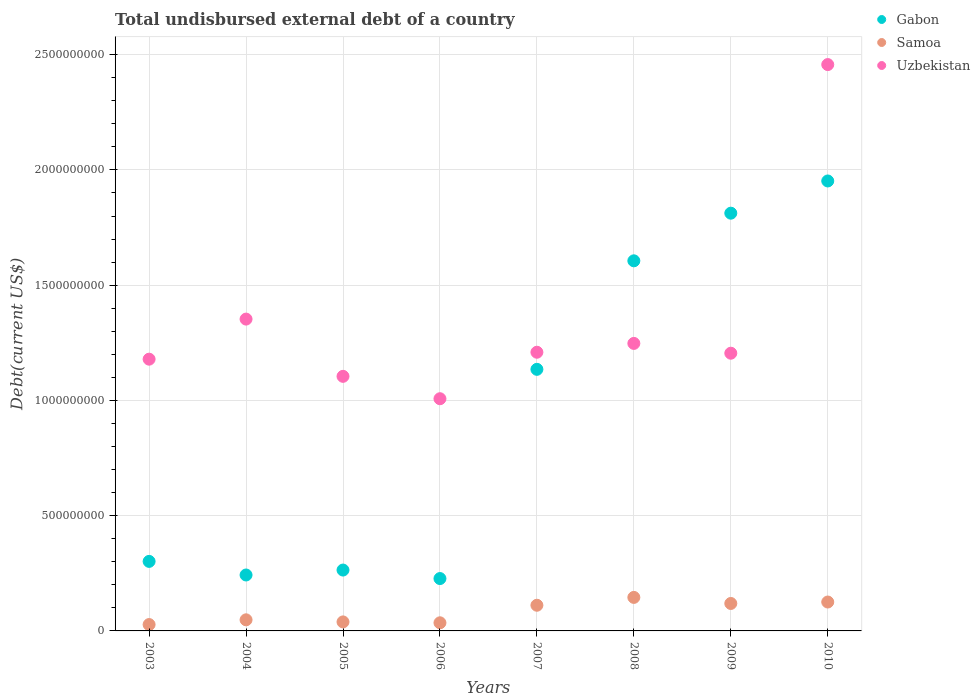Is the number of dotlines equal to the number of legend labels?
Your response must be concise. Yes. What is the total undisbursed external debt in Samoa in 2004?
Offer a terse response. 4.82e+07. Across all years, what is the maximum total undisbursed external debt in Uzbekistan?
Provide a short and direct response. 2.46e+09. Across all years, what is the minimum total undisbursed external debt in Samoa?
Ensure brevity in your answer.  2.76e+07. In which year was the total undisbursed external debt in Gabon minimum?
Keep it short and to the point. 2006. What is the total total undisbursed external debt in Samoa in the graph?
Give a very brief answer. 6.51e+08. What is the difference between the total undisbursed external debt in Gabon in 2004 and that in 2005?
Keep it short and to the point. -2.14e+07. What is the difference between the total undisbursed external debt in Gabon in 2007 and the total undisbursed external debt in Samoa in 2009?
Your response must be concise. 1.02e+09. What is the average total undisbursed external debt in Gabon per year?
Your answer should be very brief. 9.43e+08. In the year 2007, what is the difference between the total undisbursed external debt in Samoa and total undisbursed external debt in Uzbekistan?
Offer a very short reply. -1.10e+09. In how many years, is the total undisbursed external debt in Gabon greater than 2000000000 US$?
Make the answer very short. 0. What is the ratio of the total undisbursed external debt in Gabon in 2004 to that in 2008?
Make the answer very short. 0.15. Is the difference between the total undisbursed external debt in Samoa in 2006 and 2008 greater than the difference between the total undisbursed external debt in Uzbekistan in 2006 and 2008?
Your response must be concise. Yes. What is the difference between the highest and the second highest total undisbursed external debt in Samoa?
Provide a short and direct response. 2.00e+07. What is the difference between the highest and the lowest total undisbursed external debt in Samoa?
Your answer should be very brief. 1.18e+08. Is it the case that in every year, the sum of the total undisbursed external debt in Gabon and total undisbursed external debt in Samoa  is greater than the total undisbursed external debt in Uzbekistan?
Make the answer very short. No. Does the total undisbursed external debt in Gabon monotonically increase over the years?
Give a very brief answer. No. Is the total undisbursed external debt in Samoa strictly less than the total undisbursed external debt in Gabon over the years?
Make the answer very short. Yes. How many years are there in the graph?
Keep it short and to the point. 8. What is the difference between two consecutive major ticks on the Y-axis?
Ensure brevity in your answer.  5.00e+08. Are the values on the major ticks of Y-axis written in scientific E-notation?
Provide a short and direct response. No. Does the graph contain any zero values?
Keep it short and to the point. No. Where does the legend appear in the graph?
Offer a very short reply. Top right. How many legend labels are there?
Make the answer very short. 3. What is the title of the graph?
Keep it short and to the point. Total undisbursed external debt of a country. What is the label or title of the Y-axis?
Offer a very short reply. Debt(current US$). What is the Debt(current US$) in Gabon in 2003?
Provide a short and direct response. 3.02e+08. What is the Debt(current US$) of Samoa in 2003?
Ensure brevity in your answer.  2.76e+07. What is the Debt(current US$) of Uzbekistan in 2003?
Your response must be concise. 1.18e+09. What is the Debt(current US$) of Gabon in 2004?
Provide a succinct answer. 2.43e+08. What is the Debt(current US$) in Samoa in 2004?
Ensure brevity in your answer.  4.82e+07. What is the Debt(current US$) of Uzbekistan in 2004?
Ensure brevity in your answer.  1.35e+09. What is the Debt(current US$) of Gabon in 2005?
Your response must be concise. 2.64e+08. What is the Debt(current US$) in Samoa in 2005?
Provide a short and direct response. 3.91e+07. What is the Debt(current US$) of Uzbekistan in 2005?
Offer a terse response. 1.10e+09. What is the Debt(current US$) of Gabon in 2006?
Your answer should be very brief. 2.27e+08. What is the Debt(current US$) in Samoa in 2006?
Your answer should be compact. 3.53e+07. What is the Debt(current US$) of Uzbekistan in 2006?
Your answer should be compact. 1.01e+09. What is the Debt(current US$) in Gabon in 2007?
Provide a succinct answer. 1.13e+09. What is the Debt(current US$) in Samoa in 2007?
Your answer should be compact. 1.11e+08. What is the Debt(current US$) in Uzbekistan in 2007?
Give a very brief answer. 1.21e+09. What is the Debt(current US$) of Gabon in 2008?
Offer a terse response. 1.61e+09. What is the Debt(current US$) of Samoa in 2008?
Give a very brief answer. 1.45e+08. What is the Debt(current US$) in Uzbekistan in 2008?
Provide a succinct answer. 1.25e+09. What is the Debt(current US$) of Gabon in 2009?
Offer a very short reply. 1.81e+09. What is the Debt(current US$) of Samoa in 2009?
Your answer should be very brief. 1.19e+08. What is the Debt(current US$) of Uzbekistan in 2009?
Ensure brevity in your answer.  1.20e+09. What is the Debt(current US$) of Gabon in 2010?
Your answer should be very brief. 1.95e+09. What is the Debt(current US$) of Samoa in 2010?
Offer a terse response. 1.25e+08. What is the Debt(current US$) of Uzbekistan in 2010?
Make the answer very short. 2.46e+09. Across all years, what is the maximum Debt(current US$) of Gabon?
Ensure brevity in your answer.  1.95e+09. Across all years, what is the maximum Debt(current US$) in Samoa?
Ensure brevity in your answer.  1.45e+08. Across all years, what is the maximum Debt(current US$) in Uzbekistan?
Keep it short and to the point. 2.46e+09. Across all years, what is the minimum Debt(current US$) of Gabon?
Your answer should be very brief. 2.27e+08. Across all years, what is the minimum Debt(current US$) in Samoa?
Keep it short and to the point. 2.76e+07. Across all years, what is the minimum Debt(current US$) of Uzbekistan?
Offer a very short reply. 1.01e+09. What is the total Debt(current US$) of Gabon in the graph?
Ensure brevity in your answer.  7.54e+09. What is the total Debt(current US$) in Samoa in the graph?
Keep it short and to the point. 6.51e+08. What is the total Debt(current US$) of Uzbekistan in the graph?
Your response must be concise. 1.08e+1. What is the difference between the Debt(current US$) in Gabon in 2003 and that in 2004?
Keep it short and to the point. 5.90e+07. What is the difference between the Debt(current US$) of Samoa in 2003 and that in 2004?
Offer a very short reply. -2.05e+07. What is the difference between the Debt(current US$) of Uzbekistan in 2003 and that in 2004?
Your answer should be compact. -1.74e+08. What is the difference between the Debt(current US$) of Gabon in 2003 and that in 2005?
Offer a terse response. 3.76e+07. What is the difference between the Debt(current US$) in Samoa in 2003 and that in 2005?
Your response must be concise. -1.14e+07. What is the difference between the Debt(current US$) in Uzbekistan in 2003 and that in 2005?
Offer a terse response. 7.45e+07. What is the difference between the Debt(current US$) in Gabon in 2003 and that in 2006?
Provide a succinct answer. 7.45e+07. What is the difference between the Debt(current US$) in Samoa in 2003 and that in 2006?
Your answer should be very brief. -7.62e+06. What is the difference between the Debt(current US$) in Uzbekistan in 2003 and that in 2006?
Give a very brief answer. 1.72e+08. What is the difference between the Debt(current US$) in Gabon in 2003 and that in 2007?
Make the answer very short. -8.33e+08. What is the difference between the Debt(current US$) of Samoa in 2003 and that in 2007?
Offer a very short reply. -8.37e+07. What is the difference between the Debt(current US$) in Uzbekistan in 2003 and that in 2007?
Keep it short and to the point. -3.01e+07. What is the difference between the Debt(current US$) in Gabon in 2003 and that in 2008?
Your answer should be compact. -1.30e+09. What is the difference between the Debt(current US$) in Samoa in 2003 and that in 2008?
Make the answer very short. -1.18e+08. What is the difference between the Debt(current US$) in Uzbekistan in 2003 and that in 2008?
Ensure brevity in your answer.  -6.84e+07. What is the difference between the Debt(current US$) in Gabon in 2003 and that in 2009?
Your answer should be very brief. -1.51e+09. What is the difference between the Debt(current US$) in Samoa in 2003 and that in 2009?
Provide a short and direct response. -9.15e+07. What is the difference between the Debt(current US$) of Uzbekistan in 2003 and that in 2009?
Provide a short and direct response. -2.59e+07. What is the difference between the Debt(current US$) in Gabon in 2003 and that in 2010?
Offer a very short reply. -1.65e+09. What is the difference between the Debt(current US$) in Samoa in 2003 and that in 2010?
Your response must be concise. -9.78e+07. What is the difference between the Debt(current US$) in Uzbekistan in 2003 and that in 2010?
Provide a succinct answer. -1.28e+09. What is the difference between the Debt(current US$) in Gabon in 2004 and that in 2005?
Offer a very short reply. -2.14e+07. What is the difference between the Debt(current US$) in Samoa in 2004 and that in 2005?
Your answer should be compact. 9.09e+06. What is the difference between the Debt(current US$) in Uzbekistan in 2004 and that in 2005?
Offer a very short reply. 2.48e+08. What is the difference between the Debt(current US$) of Gabon in 2004 and that in 2006?
Your response must be concise. 1.55e+07. What is the difference between the Debt(current US$) in Samoa in 2004 and that in 2006?
Your response must be concise. 1.29e+07. What is the difference between the Debt(current US$) of Uzbekistan in 2004 and that in 2006?
Provide a short and direct response. 3.45e+08. What is the difference between the Debt(current US$) of Gabon in 2004 and that in 2007?
Your answer should be compact. -8.92e+08. What is the difference between the Debt(current US$) of Samoa in 2004 and that in 2007?
Make the answer very short. -6.32e+07. What is the difference between the Debt(current US$) of Uzbekistan in 2004 and that in 2007?
Ensure brevity in your answer.  1.44e+08. What is the difference between the Debt(current US$) in Gabon in 2004 and that in 2008?
Offer a terse response. -1.36e+09. What is the difference between the Debt(current US$) of Samoa in 2004 and that in 2008?
Your answer should be compact. -9.73e+07. What is the difference between the Debt(current US$) in Uzbekistan in 2004 and that in 2008?
Keep it short and to the point. 1.05e+08. What is the difference between the Debt(current US$) of Gabon in 2004 and that in 2009?
Your response must be concise. -1.57e+09. What is the difference between the Debt(current US$) in Samoa in 2004 and that in 2009?
Provide a short and direct response. -7.09e+07. What is the difference between the Debt(current US$) of Uzbekistan in 2004 and that in 2009?
Ensure brevity in your answer.  1.48e+08. What is the difference between the Debt(current US$) in Gabon in 2004 and that in 2010?
Provide a short and direct response. -1.71e+09. What is the difference between the Debt(current US$) in Samoa in 2004 and that in 2010?
Provide a succinct answer. -7.72e+07. What is the difference between the Debt(current US$) in Uzbekistan in 2004 and that in 2010?
Provide a succinct answer. -1.10e+09. What is the difference between the Debt(current US$) of Gabon in 2005 and that in 2006?
Your answer should be compact. 3.69e+07. What is the difference between the Debt(current US$) of Samoa in 2005 and that in 2006?
Provide a succinct answer. 3.82e+06. What is the difference between the Debt(current US$) of Uzbekistan in 2005 and that in 2006?
Keep it short and to the point. 9.71e+07. What is the difference between the Debt(current US$) in Gabon in 2005 and that in 2007?
Offer a terse response. -8.71e+08. What is the difference between the Debt(current US$) in Samoa in 2005 and that in 2007?
Offer a terse response. -7.23e+07. What is the difference between the Debt(current US$) in Uzbekistan in 2005 and that in 2007?
Your answer should be very brief. -1.05e+08. What is the difference between the Debt(current US$) of Gabon in 2005 and that in 2008?
Offer a terse response. -1.34e+09. What is the difference between the Debt(current US$) of Samoa in 2005 and that in 2008?
Make the answer very short. -1.06e+08. What is the difference between the Debt(current US$) in Uzbekistan in 2005 and that in 2008?
Offer a very short reply. -1.43e+08. What is the difference between the Debt(current US$) in Gabon in 2005 and that in 2009?
Offer a very short reply. -1.55e+09. What is the difference between the Debt(current US$) in Samoa in 2005 and that in 2009?
Ensure brevity in your answer.  -8.00e+07. What is the difference between the Debt(current US$) in Uzbekistan in 2005 and that in 2009?
Make the answer very short. -1.00e+08. What is the difference between the Debt(current US$) in Gabon in 2005 and that in 2010?
Your response must be concise. -1.69e+09. What is the difference between the Debt(current US$) of Samoa in 2005 and that in 2010?
Keep it short and to the point. -8.63e+07. What is the difference between the Debt(current US$) in Uzbekistan in 2005 and that in 2010?
Provide a succinct answer. -1.35e+09. What is the difference between the Debt(current US$) in Gabon in 2006 and that in 2007?
Offer a terse response. -9.08e+08. What is the difference between the Debt(current US$) in Samoa in 2006 and that in 2007?
Keep it short and to the point. -7.61e+07. What is the difference between the Debt(current US$) of Uzbekistan in 2006 and that in 2007?
Give a very brief answer. -2.02e+08. What is the difference between the Debt(current US$) in Gabon in 2006 and that in 2008?
Offer a terse response. -1.38e+09. What is the difference between the Debt(current US$) in Samoa in 2006 and that in 2008?
Ensure brevity in your answer.  -1.10e+08. What is the difference between the Debt(current US$) of Uzbekistan in 2006 and that in 2008?
Give a very brief answer. -2.40e+08. What is the difference between the Debt(current US$) in Gabon in 2006 and that in 2009?
Your answer should be very brief. -1.59e+09. What is the difference between the Debt(current US$) in Samoa in 2006 and that in 2009?
Give a very brief answer. -8.38e+07. What is the difference between the Debt(current US$) of Uzbekistan in 2006 and that in 2009?
Provide a short and direct response. -1.97e+08. What is the difference between the Debt(current US$) in Gabon in 2006 and that in 2010?
Provide a short and direct response. -1.72e+09. What is the difference between the Debt(current US$) of Samoa in 2006 and that in 2010?
Keep it short and to the point. -9.01e+07. What is the difference between the Debt(current US$) in Uzbekistan in 2006 and that in 2010?
Give a very brief answer. -1.45e+09. What is the difference between the Debt(current US$) of Gabon in 2007 and that in 2008?
Your response must be concise. -4.71e+08. What is the difference between the Debt(current US$) of Samoa in 2007 and that in 2008?
Ensure brevity in your answer.  -3.40e+07. What is the difference between the Debt(current US$) in Uzbekistan in 2007 and that in 2008?
Give a very brief answer. -3.83e+07. What is the difference between the Debt(current US$) in Gabon in 2007 and that in 2009?
Ensure brevity in your answer.  -6.77e+08. What is the difference between the Debt(current US$) of Samoa in 2007 and that in 2009?
Ensure brevity in your answer.  -7.73e+06. What is the difference between the Debt(current US$) of Uzbekistan in 2007 and that in 2009?
Keep it short and to the point. 4.21e+06. What is the difference between the Debt(current US$) of Gabon in 2007 and that in 2010?
Offer a terse response. -8.17e+08. What is the difference between the Debt(current US$) of Samoa in 2007 and that in 2010?
Give a very brief answer. -1.40e+07. What is the difference between the Debt(current US$) in Uzbekistan in 2007 and that in 2010?
Your answer should be compact. -1.25e+09. What is the difference between the Debt(current US$) of Gabon in 2008 and that in 2009?
Provide a short and direct response. -2.07e+08. What is the difference between the Debt(current US$) in Samoa in 2008 and that in 2009?
Your response must be concise. 2.63e+07. What is the difference between the Debt(current US$) of Uzbekistan in 2008 and that in 2009?
Your response must be concise. 4.25e+07. What is the difference between the Debt(current US$) of Gabon in 2008 and that in 2010?
Provide a succinct answer. -3.46e+08. What is the difference between the Debt(current US$) of Samoa in 2008 and that in 2010?
Offer a terse response. 2.00e+07. What is the difference between the Debt(current US$) of Uzbekistan in 2008 and that in 2010?
Keep it short and to the point. -1.21e+09. What is the difference between the Debt(current US$) in Gabon in 2009 and that in 2010?
Provide a short and direct response. -1.40e+08. What is the difference between the Debt(current US$) of Samoa in 2009 and that in 2010?
Make the answer very short. -6.29e+06. What is the difference between the Debt(current US$) in Uzbekistan in 2009 and that in 2010?
Give a very brief answer. -1.25e+09. What is the difference between the Debt(current US$) in Gabon in 2003 and the Debt(current US$) in Samoa in 2004?
Offer a terse response. 2.53e+08. What is the difference between the Debt(current US$) in Gabon in 2003 and the Debt(current US$) in Uzbekistan in 2004?
Give a very brief answer. -1.05e+09. What is the difference between the Debt(current US$) in Samoa in 2003 and the Debt(current US$) in Uzbekistan in 2004?
Make the answer very short. -1.33e+09. What is the difference between the Debt(current US$) of Gabon in 2003 and the Debt(current US$) of Samoa in 2005?
Make the answer very short. 2.63e+08. What is the difference between the Debt(current US$) of Gabon in 2003 and the Debt(current US$) of Uzbekistan in 2005?
Offer a very short reply. -8.03e+08. What is the difference between the Debt(current US$) in Samoa in 2003 and the Debt(current US$) in Uzbekistan in 2005?
Provide a succinct answer. -1.08e+09. What is the difference between the Debt(current US$) of Gabon in 2003 and the Debt(current US$) of Samoa in 2006?
Your response must be concise. 2.66e+08. What is the difference between the Debt(current US$) of Gabon in 2003 and the Debt(current US$) of Uzbekistan in 2006?
Ensure brevity in your answer.  -7.06e+08. What is the difference between the Debt(current US$) of Samoa in 2003 and the Debt(current US$) of Uzbekistan in 2006?
Keep it short and to the point. -9.80e+08. What is the difference between the Debt(current US$) in Gabon in 2003 and the Debt(current US$) in Samoa in 2007?
Keep it short and to the point. 1.90e+08. What is the difference between the Debt(current US$) of Gabon in 2003 and the Debt(current US$) of Uzbekistan in 2007?
Provide a succinct answer. -9.07e+08. What is the difference between the Debt(current US$) in Samoa in 2003 and the Debt(current US$) in Uzbekistan in 2007?
Provide a short and direct response. -1.18e+09. What is the difference between the Debt(current US$) of Gabon in 2003 and the Debt(current US$) of Samoa in 2008?
Keep it short and to the point. 1.56e+08. What is the difference between the Debt(current US$) in Gabon in 2003 and the Debt(current US$) in Uzbekistan in 2008?
Offer a terse response. -9.46e+08. What is the difference between the Debt(current US$) in Samoa in 2003 and the Debt(current US$) in Uzbekistan in 2008?
Your response must be concise. -1.22e+09. What is the difference between the Debt(current US$) in Gabon in 2003 and the Debt(current US$) in Samoa in 2009?
Provide a short and direct response. 1.83e+08. What is the difference between the Debt(current US$) in Gabon in 2003 and the Debt(current US$) in Uzbekistan in 2009?
Keep it short and to the point. -9.03e+08. What is the difference between the Debt(current US$) in Samoa in 2003 and the Debt(current US$) in Uzbekistan in 2009?
Provide a short and direct response. -1.18e+09. What is the difference between the Debt(current US$) of Gabon in 2003 and the Debt(current US$) of Samoa in 2010?
Offer a very short reply. 1.76e+08. What is the difference between the Debt(current US$) in Gabon in 2003 and the Debt(current US$) in Uzbekistan in 2010?
Give a very brief answer. -2.16e+09. What is the difference between the Debt(current US$) in Samoa in 2003 and the Debt(current US$) in Uzbekistan in 2010?
Your answer should be compact. -2.43e+09. What is the difference between the Debt(current US$) of Gabon in 2004 and the Debt(current US$) of Samoa in 2005?
Your response must be concise. 2.04e+08. What is the difference between the Debt(current US$) of Gabon in 2004 and the Debt(current US$) of Uzbekistan in 2005?
Provide a succinct answer. -8.62e+08. What is the difference between the Debt(current US$) of Samoa in 2004 and the Debt(current US$) of Uzbekistan in 2005?
Make the answer very short. -1.06e+09. What is the difference between the Debt(current US$) in Gabon in 2004 and the Debt(current US$) in Samoa in 2006?
Your response must be concise. 2.07e+08. What is the difference between the Debt(current US$) in Gabon in 2004 and the Debt(current US$) in Uzbekistan in 2006?
Provide a succinct answer. -7.65e+08. What is the difference between the Debt(current US$) in Samoa in 2004 and the Debt(current US$) in Uzbekistan in 2006?
Offer a very short reply. -9.59e+08. What is the difference between the Debt(current US$) of Gabon in 2004 and the Debt(current US$) of Samoa in 2007?
Ensure brevity in your answer.  1.31e+08. What is the difference between the Debt(current US$) of Gabon in 2004 and the Debt(current US$) of Uzbekistan in 2007?
Provide a short and direct response. -9.66e+08. What is the difference between the Debt(current US$) in Samoa in 2004 and the Debt(current US$) in Uzbekistan in 2007?
Provide a short and direct response. -1.16e+09. What is the difference between the Debt(current US$) in Gabon in 2004 and the Debt(current US$) in Samoa in 2008?
Your answer should be compact. 9.73e+07. What is the difference between the Debt(current US$) in Gabon in 2004 and the Debt(current US$) in Uzbekistan in 2008?
Ensure brevity in your answer.  -1.00e+09. What is the difference between the Debt(current US$) of Samoa in 2004 and the Debt(current US$) of Uzbekistan in 2008?
Provide a succinct answer. -1.20e+09. What is the difference between the Debt(current US$) in Gabon in 2004 and the Debt(current US$) in Samoa in 2009?
Keep it short and to the point. 1.24e+08. What is the difference between the Debt(current US$) in Gabon in 2004 and the Debt(current US$) in Uzbekistan in 2009?
Your response must be concise. -9.62e+08. What is the difference between the Debt(current US$) of Samoa in 2004 and the Debt(current US$) of Uzbekistan in 2009?
Make the answer very short. -1.16e+09. What is the difference between the Debt(current US$) in Gabon in 2004 and the Debt(current US$) in Samoa in 2010?
Offer a terse response. 1.17e+08. What is the difference between the Debt(current US$) of Gabon in 2004 and the Debt(current US$) of Uzbekistan in 2010?
Offer a terse response. -2.21e+09. What is the difference between the Debt(current US$) in Samoa in 2004 and the Debt(current US$) in Uzbekistan in 2010?
Your answer should be very brief. -2.41e+09. What is the difference between the Debt(current US$) of Gabon in 2005 and the Debt(current US$) of Samoa in 2006?
Your answer should be very brief. 2.29e+08. What is the difference between the Debt(current US$) of Gabon in 2005 and the Debt(current US$) of Uzbekistan in 2006?
Your answer should be very brief. -7.43e+08. What is the difference between the Debt(current US$) of Samoa in 2005 and the Debt(current US$) of Uzbekistan in 2006?
Keep it short and to the point. -9.68e+08. What is the difference between the Debt(current US$) in Gabon in 2005 and the Debt(current US$) in Samoa in 2007?
Make the answer very short. 1.53e+08. What is the difference between the Debt(current US$) of Gabon in 2005 and the Debt(current US$) of Uzbekistan in 2007?
Keep it short and to the point. -9.45e+08. What is the difference between the Debt(current US$) of Samoa in 2005 and the Debt(current US$) of Uzbekistan in 2007?
Ensure brevity in your answer.  -1.17e+09. What is the difference between the Debt(current US$) in Gabon in 2005 and the Debt(current US$) in Samoa in 2008?
Ensure brevity in your answer.  1.19e+08. What is the difference between the Debt(current US$) of Gabon in 2005 and the Debt(current US$) of Uzbekistan in 2008?
Make the answer very short. -9.83e+08. What is the difference between the Debt(current US$) of Samoa in 2005 and the Debt(current US$) of Uzbekistan in 2008?
Ensure brevity in your answer.  -1.21e+09. What is the difference between the Debt(current US$) of Gabon in 2005 and the Debt(current US$) of Samoa in 2009?
Ensure brevity in your answer.  1.45e+08. What is the difference between the Debt(current US$) in Gabon in 2005 and the Debt(current US$) in Uzbekistan in 2009?
Provide a succinct answer. -9.41e+08. What is the difference between the Debt(current US$) of Samoa in 2005 and the Debt(current US$) of Uzbekistan in 2009?
Your answer should be compact. -1.17e+09. What is the difference between the Debt(current US$) in Gabon in 2005 and the Debt(current US$) in Samoa in 2010?
Your answer should be very brief. 1.39e+08. What is the difference between the Debt(current US$) of Gabon in 2005 and the Debt(current US$) of Uzbekistan in 2010?
Ensure brevity in your answer.  -2.19e+09. What is the difference between the Debt(current US$) in Samoa in 2005 and the Debt(current US$) in Uzbekistan in 2010?
Give a very brief answer. -2.42e+09. What is the difference between the Debt(current US$) in Gabon in 2006 and the Debt(current US$) in Samoa in 2007?
Make the answer very short. 1.16e+08. What is the difference between the Debt(current US$) of Gabon in 2006 and the Debt(current US$) of Uzbekistan in 2007?
Provide a short and direct response. -9.82e+08. What is the difference between the Debt(current US$) of Samoa in 2006 and the Debt(current US$) of Uzbekistan in 2007?
Your answer should be very brief. -1.17e+09. What is the difference between the Debt(current US$) in Gabon in 2006 and the Debt(current US$) in Samoa in 2008?
Keep it short and to the point. 8.18e+07. What is the difference between the Debt(current US$) of Gabon in 2006 and the Debt(current US$) of Uzbekistan in 2008?
Give a very brief answer. -1.02e+09. What is the difference between the Debt(current US$) in Samoa in 2006 and the Debt(current US$) in Uzbekistan in 2008?
Your answer should be very brief. -1.21e+09. What is the difference between the Debt(current US$) in Gabon in 2006 and the Debt(current US$) in Samoa in 2009?
Offer a very short reply. 1.08e+08. What is the difference between the Debt(current US$) of Gabon in 2006 and the Debt(current US$) of Uzbekistan in 2009?
Ensure brevity in your answer.  -9.78e+08. What is the difference between the Debt(current US$) in Samoa in 2006 and the Debt(current US$) in Uzbekistan in 2009?
Make the answer very short. -1.17e+09. What is the difference between the Debt(current US$) in Gabon in 2006 and the Debt(current US$) in Samoa in 2010?
Offer a very short reply. 1.02e+08. What is the difference between the Debt(current US$) in Gabon in 2006 and the Debt(current US$) in Uzbekistan in 2010?
Ensure brevity in your answer.  -2.23e+09. What is the difference between the Debt(current US$) of Samoa in 2006 and the Debt(current US$) of Uzbekistan in 2010?
Your response must be concise. -2.42e+09. What is the difference between the Debt(current US$) of Gabon in 2007 and the Debt(current US$) of Samoa in 2008?
Offer a terse response. 9.90e+08. What is the difference between the Debt(current US$) in Gabon in 2007 and the Debt(current US$) in Uzbekistan in 2008?
Your answer should be compact. -1.12e+08. What is the difference between the Debt(current US$) in Samoa in 2007 and the Debt(current US$) in Uzbekistan in 2008?
Your answer should be compact. -1.14e+09. What is the difference between the Debt(current US$) in Gabon in 2007 and the Debt(current US$) in Samoa in 2009?
Provide a short and direct response. 1.02e+09. What is the difference between the Debt(current US$) of Gabon in 2007 and the Debt(current US$) of Uzbekistan in 2009?
Provide a succinct answer. -6.99e+07. What is the difference between the Debt(current US$) of Samoa in 2007 and the Debt(current US$) of Uzbekistan in 2009?
Offer a very short reply. -1.09e+09. What is the difference between the Debt(current US$) of Gabon in 2007 and the Debt(current US$) of Samoa in 2010?
Ensure brevity in your answer.  1.01e+09. What is the difference between the Debt(current US$) in Gabon in 2007 and the Debt(current US$) in Uzbekistan in 2010?
Make the answer very short. -1.32e+09. What is the difference between the Debt(current US$) of Samoa in 2007 and the Debt(current US$) of Uzbekistan in 2010?
Offer a very short reply. -2.35e+09. What is the difference between the Debt(current US$) in Gabon in 2008 and the Debt(current US$) in Samoa in 2009?
Make the answer very short. 1.49e+09. What is the difference between the Debt(current US$) of Gabon in 2008 and the Debt(current US$) of Uzbekistan in 2009?
Give a very brief answer. 4.01e+08. What is the difference between the Debt(current US$) of Samoa in 2008 and the Debt(current US$) of Uzbekistan in 2009?
Give a very brief answer. -1.06e+09. What is the difference between the Debt(current US$) in Gabon in 2008 and the Debt(current US$) in Samoa in 2010?
Your response must be concise. 1.48e+09. What is the difference between the Debt(current US$) in Gabon in 2008 and the Debt(current US$) in Uzbekistan in 2010?
Provide a succinct answer. -8.51e+08. What is the difference between the Debt(current US$) of Samoa in 2008 and the Debt(current US$) of Uzbekistan in 2010?
Provide a short and direct response. -2.31e+09. What is the difference between the Debt(current US$) in Gabon in 2009 and the Debt(current US$) in Samoa in 2010?
Keep it short and to the point. 1.69e+09. What is the difference between the Debt(current US$) of Gabon in 2009 and the Debt(current US$) of Uzbekistan in 2010?
Keep it short and to the point. -6.45e+08. What is the difference between the Debt(current US$) of Samoa in 2009 and the Debt(current US$) of Uzbekistan in 2010?
Provide a short and direct response. -2.34e+09. What is the average Debt(current US$) in Gabon per year?
Offer a very short reply. 9.43e+08. What is the average Debt(current US$) of Samoa per year?
Provide a succinct answer. 8.14e+07. What is the average Debt(current US$) of Uzbekistan per year?
Provide a short and direct response. 1.35e+09. In the year 2003, what is the difference between the Debt(current US$) of Gabon and Debt(current US$) of Samoa?
Ensure brevity in your answer.  2.74e+08. In the year 2003, what is the difference between the Debt(current US$) of Gabon and Debt(current US$) of Uzbekistan?
Your answer should be very brief. -8.77e+08. In the year 2003, what is the difference between the Debt(current US$) in Samoa and Debt(current US$) in Uzbekistan?
Your answer should be very brief. -1.15e+09. In the year 2004, what is the difference between the Debt(current US$) of Gabon and Debt(current US$) of Samoa?
Keep it short and to the point. 1.95e+08. In the year 2004, what is the difference between the Debt(current US$) in Gabon and Debt(current US$) in Uzbekistan?
Provide a short and direct response. -1.11e+09. In the year 2004, what is the difference between the Debt(current US$) in Samoa and Debt(current US$) in Uzbekistan?
Keep it short and to the point. -1.30e+09. In the year 2005, what is the difference between the Debt(current US$) of Gabon and Debt(current US$) of Samoa?
Your answer should be very brief. 2.25e+08. In the year 2005, what is the difference between the Debt(current US$) of Gabon and Debt(current US$) of Uzbekistan?
Ensure brevity in your answer.  -8.40e+08. In the year 2005, what is the difference between the Debt(current US$) of Samoa and Debt(current US$) of Uzbekistan?
Your answer should be very brief. -1.07e+09. In the year 2006, what is the difference between the Debt(current US$) in Gabon and Debt(current US$) in Samoa?
Your response must be concise. 1.92e+08. In the year 2006, what is the difference between the Debt(current US$) in Gabon and Debt(current US$) in Uzbekistan?
Provide a succinct answer. -7.80e+08. In the year 2006, what is the difference between the Debt(current US$) of Samoa and Debt(current US$) of Uzbekistan?
Keep it short and to the point. -9.72e+08. In the year 2007, what is the difference between the Debt(current US$) in Gabon and Debt(current US$) in Samoa?
Your response must be concise. 1.02e+09. In the year 2007, what is the difference between the Debt(current US$) in Gabon and Debt(current US$) in Uzbekistan?
Keep it short and to the point. -7.42e+07. In the year 2007, what is the difference between the Debt(current US$) of Samoa and Debt(current US$) of Uzbekistan?
Offer a terse response. -1.10e+09. In the year 2008, what is the difference between the Debt(current US$) in Gabon and Debt(current US$) in Samoa?
Provide a short and direct response. 1.46e+09. In the year 2008, what is the difference between the Debt(current US$) in Gabon and Debt(current US$) in Uzbekistan?
Give a very brief answer. 3.58e+08. In the year 2008, what is the difference between the Debt(current US$) in Samoa and Debt(current US$) in Uzbekistan?
Keep it short and to the point. -1.10e+09. In the year 2009, what is the difference between the Debt(current US$) of Gabon and Debt(current US$) of Samoa?
Ensure brevity in your answer.  1.69e+09. In the year 2009, what is the difference between the Debt(current US$) of Gabon and Debt(current US$) of Uzbekistan?
Offer a terse response. 6.08e+08. In the year 2009, what is the difference between the Debt(current US$) in Samoa and Debt(current US$) in Uzbekistan?
Provide a succinct answer. -1.09e+09. In the year 2010, what is the difference between the Debt(current US$) of Gabon and Debt(current US$) of Samoa?
Give a very brief answer. 1.83e+09. In the year 2010, what is the difference between the Debt(current US$) in Gabon and Debt(current US$) in Uzbekistan?
Offer a very short reply. -5.05e+08. In the year 2010, what is the difference between the Debt(current US$) of Samoa and Debt(current US$) of Uzbekistan?
Give a very brief answer. -2.33e+09. What is the ratio of the Debt(current US$) of Gabon in 2003 to that in 2004?
Provide a succinct answer. 1.24. What is the ratio of the Debt(current US$) in Samoa in 2003 to that in 2004?
Keep it short and to the point. 0.57. What is the ratio of the Debt(current US$) in Uzbekistan in 2003 to that in 2004?
Give a very brief answer. 0.87. What is the ratio of the Debt(current US$) in Gabon in 2003 to that in 2005?
Your answer should be compact. 1.14. What is the ratio of the Debt(current US$) of Samoa in 2003 to that in 2005?
Offer a very short reply. 0.71. What is the ratio of the Debt(current US$) of Uzbekistan in 2003 to that in 2005?
Give a very brief answer. 1.07. What is the ratio of the Debt(current US$) of Gabon in 2003 to that in 2006?
Your response must be concise. 1.33. What is the ratio of the Debt(current US$) of Samoa in 2003 to that in 2006?
Offer a very short reply. 0.78. What is the ratio of the Debt(current US$) in Uzbekistan in 2003 to that in 2006?
Your response must be concise. 1.17. What is the ratio of the Debt(current US$) of Gabon in 2003 to that in 2007?
Make the answer very short. 0.27. What is the ratio of the Debt(current US$) in Samoa in 2003 to that in 2007?
Ensure brevity in your answer.  0.25. What is the ratio of the Debt(current US$) in Uzbekistan in 2003 to that in 2007?
Ensure brevity in your answer.  0.98. What is the ratio of the Debt(current US$) of Gabon in 2003 to that in 2008?
Ensure brevity in your answer.  0.19. What is the ratio of the Debt(current US$) of Samoa in 2003 to that in 2008?
Provide a succinct answer. 0.19. What is the ratio of the Debt(current US$) of Uzbekistan in 2003 to that in 2008?
Your response must be concise. 0.95. What is the ratio of the Debt(current US$) in Gabon in 2003 to that in 2009?
Make the answer very short. 0.17. What is the ratio of the Debt(current US$) in Samoa in 2003 to that in 2009?
Give a very brief answer. 0.23. What is the ratio of the Debt(current US$) of Uzbekistan in 2003 to that in 2009?
Offer a very short reply. 0.98. What is the ratio of the Debt(current US$) in Gabon in 2003 to that in 2010?
Your answer should be very brief. 0.15. What is the ratio of the Debt(current US$) of Samoa in 2003 to that in 2010?
Your response must be concise. 0.22. What is the ratio of the Debt(current US$) of Uzbekistan in 2003 to that in 2010?
Your answer should be compact. 0.48. What is the ratio of the Debt(current US$) in Gabon in 2004 to that in 2005?
Give a very brief answer. 0.92. What is the ratio of the Debt(current US$) in Samoa in 2004 to that in 2005?
Provide a short and direct response. 1.23. What is the ratio of the Debt(current US$) in Uzbekistan in 2004 to that in 2005?
Offer a very short reply. 1.22. What is the ratio of the Debt(current US$) of Gabon in 2004 to that in 2006?
Your answer should be compact. 1.07. What is the ratio of the Debt(current US$) in Samoa in 2004 to that in 2006?
Ensure brevity in your answer.  1.37. What is the ratio of the Debt(current US$) of Uzbekistan in 2004 to that in 2006?
Your answer should be compact. 1.34. What is the ratio of the Debt(current US$) in Gabon in 2004 to that in 2007?
Keep it short and to the point. 0.21. What is the ratio of the Debt(current US$) in Samoa in 2004 to that in 2007?
Make the answer very short. 0.43. What is the ratio of the Debt(current US$) of Uzbekistan in 2004 to that in 2007?
Provide a succinct answer. 1.12. What is the ratio of the Debt(current US$) in Gabon in 2004 to that in 2008?
Ensure brevity in your answer.  0.15. What is the ratio of the Debt(current US$) of Samoa in 2004 to that in 2008?
Give a very brief answer. 0.33. What is the ratio of the Debt(current US$) in Uzbekistan in 2004 to that in 2008?
Provide a succinct answer. 1.08. What is the ratio of the Debt(current US$) in Gabon in 2004 to that in 2009?
Make the answer very short. 0.13. What is the ratio of the Debt(current US$) in Samoa in 2004 to that in 2009?
Offer a terse response. 0.4. What is the ratio of the Debt(current US$) of Uzbekistan in 2004 to that in 2009?
Keep it short and to the point. 1.12. What is the ratio of the Debt(current US$) in Gabon in 2004 to that in 2010?
Make the answer very short. 0.12. What is the ratio of the Debt(current US$) in Samoa in 2004 to that in 2010?
Provide a short and direct response. 0.38. What is the ratio of the Debt(current US$) of Uzbekistan in 2004 to that in 2010?
Your answer should be compact. 0.55. What is the ratio of the Debt(current US$) in Gabon in 2005 to that in 2006?
Your answer should be very brief. 1.16. What is the ratio of the Debt(current US$) of Samoa in 2005 to that in 2006?
Offer a terse response. 1.11. What is the ratio of the Debt(current US$) of Uzbekistan in 2005 to that in 2006?
Provide a succinct answer. 1.1. What is the ratio of the Debt(current US$) in Gabon in 2005 to that in 2007?
Make the answer very short. 0.23. What is the ratio of the Debt(current US$) of Samoa in 2005 to that in 2007?
Your answer should be compact. 0.35. What is the ratio of the Debt(current US$) in Uzbekistan in 2005 to that in 2007?
Your answer should be compact. 0.91. What is the ratio of the Debt(current US$) of Gabon in 2005 to that in 2008?
Offer a very short reply. 0.16. What is the ratio of the Debt(current US$) in Samoa in 2005 to that in 2008?
Offer a very short reply. 0.27. What is the ratio of the Debt(current US$) in Uzbekistan in 2005 to that in 2008?
Your answer should be compact. 0.89. What is the ratio of the Debt(current US$) of Gabon in 2005 to that in 2009?
Ensure brevity in your answer.  0.15. What is the ratio of the Debt(current US$) of Samoa in 2005 to that in 2009?
Your answer should be very brief. 0.33. What is the ratio of the Debt(current US$) of Uzbekistan in 2005 to that in 2009?
Provide a succinct answer. 0.92. What is the ratio of the Debt(current US$) of Gabon in 2005 to that in 2010?
Your answer should be very brief. 0.14. What is the ratio of the Debt(current US$) in Samoa in 2005 to that in 2010?
Provide a succinct answer. 0.31. What is the ratio of the Debt(current US$) in Uzbekistan in 2005 to that in 2010?
Your answer should be compact. 0.45. What is the ratio of the Debt(current US$) of Gabon in 2006 to that in 2007?
Keep it short and to the point. 0.2. What is the ratio of the Debt(current US$) of Samoa in 2006 to that in 2007?
Give a very brief answer. 0.32. What is the ratio of the Debt(current US$) of Uzbekistan in 2006 to that in 2007?
Provide a short and direct response. 0.83. What is the ratio of the Debt(current US$) in Gabon in 2006 to that in 2008?
Provide a succinct answer. 0.14. What is the ratio of the Debt(current US$) in Samoa in 2006 to that in 2008?
Ensure brevity in your answer.  0.24. What is the ratio of the Debt(current US$) of Uzbekistan in 2006 to that in 2008?
Make the answer very short. 0.81. What is the ratio of the Debt(current US$) in Gabon in 2006 to that in 2009?
Make the answer very short. 0.13. What is the ratio of the Debt(current US$) in Samoa in 2006 to that in 2009?
Your response must be concise. 0.3. What is the ratio of the Debt(current US$) in Uzbekistan in 2006 to that in 2009?
Offer a terse response. 0.84. What is the ratio of the Debt(current US$) in Gabon in 2006 to that in 2010?
Your response must be concise. 0.12. What is the ratio of the Debt(current US$) in Samoa in 2006 to that in 2010?
Offer a very short reply. 0.28. What is the ratio of the Debt(current US$) in Uzbekistan in 2006 to that in 2010?
Provide a short and direct response. 0.41. What is the ratio of the Debt(current US$) of Gabon in 2007 to that in 2008?
Offer a terse response. 0.71. What is the ratio of the Debt(current US$) in Samoa in 2007 to that in 2008?
Your answer should be compact. 0.77. What is the ratio of the Debt(current US$) of Uzbekistan in 2007 to that in 2008?
Make the answer very short. 0.97. What is the ratio of the Debt(current US$) of Gabon in 2007 to that in 2009?
Your answer should be very brief. 0.63. What is the ratio of the Debt(current US$) of Samoa in 2007 to that in 2009?
Provide a short and direct response. 0.94. What is the ratio of the Debt(current US$) of Gabon in 2007 to that in 2010?
Offer a very short reply. 0.58. What is the ratio of the Debt(current US$) in Samoa in 2007 to that in 2010?
Provide a short and direct response. 0.89. What is the ratio of the Debt(current US$) in Uzbekistan in 2007 to that in 2010?
Offer a very short reply. 0.49. What is the ratio of the Debt(current US$) of Gabon in 2008 to that in 2009?
Keep it short and to the point. 0.89. What is the ratio of the Debt(current US$) in Samoa in 2008 to that in 2009?
Keep it short and to the point. 1.22. What is the ratio of the Debt(current US$) of Uzbekistan in 2008 to that in 2009?
Make the answer very short. 1.04. What is the ratio of the Debt(current US$) in Gabon in 2008 to that in 2010?
Keep it short and to the point. 0.82. What is the ratio of the Debt(current US$) in Samoa in 2008 to that in 2010?
Provide a short and direct response. 1.16. What is the ratio of the Debt(current US$) in Uzbekistan in 2008 to that in 2010?
Provide a succinct answer. 0.51. What is the ratio of the Debt(current US$) in Gabon in 2009 to that in 2010?
Provide a succinct answer. 0.93. What is the ratio of the Debt(current US$) in Samoa in 2009 to that in 2010?
Your response must be concise. 0.95. What is the ratio of the Debt(current US$) in Uzbekistan in 2009 to that in 2010?
Give a very brief answer. 0.49. What is the difference between the highest and the second highest Debt(current US$) in Gabon?
Offer a very short reply. 1.40e+08. What is the difference between the highest and the second highest Debt(current US$) of Samoa?
Give a very brief answer. 2.00e+07. What is the difference between the highest and the second highest Debt(current US$) in Uzbekistan?
Ensure brevity in your answer.  1.10e+09. What is the difference between the highest and the lowest Debt(current US$) in Gabon?
Keep it short and to the point. 1.72e+09. What is the difference between the highest and the lowest Debt(current US$) of Samoa?
Make the answer very short. 1.18e+08. What is the difference between the highest and the lowest Debt(current US$) in Uzbekistan?
Offer a terse response. 1.45e+09. 